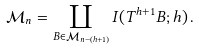Convert formula to latex. <formula><loc_0><loc_0><loc_500><loc_500>\mathcal { M } _ { n } = \coprod _ { B \in \mathcal { M } _ { n - ( h + 1 ) } } I ( T ^ { h + 1 } B ; h ) \, .</formula> 